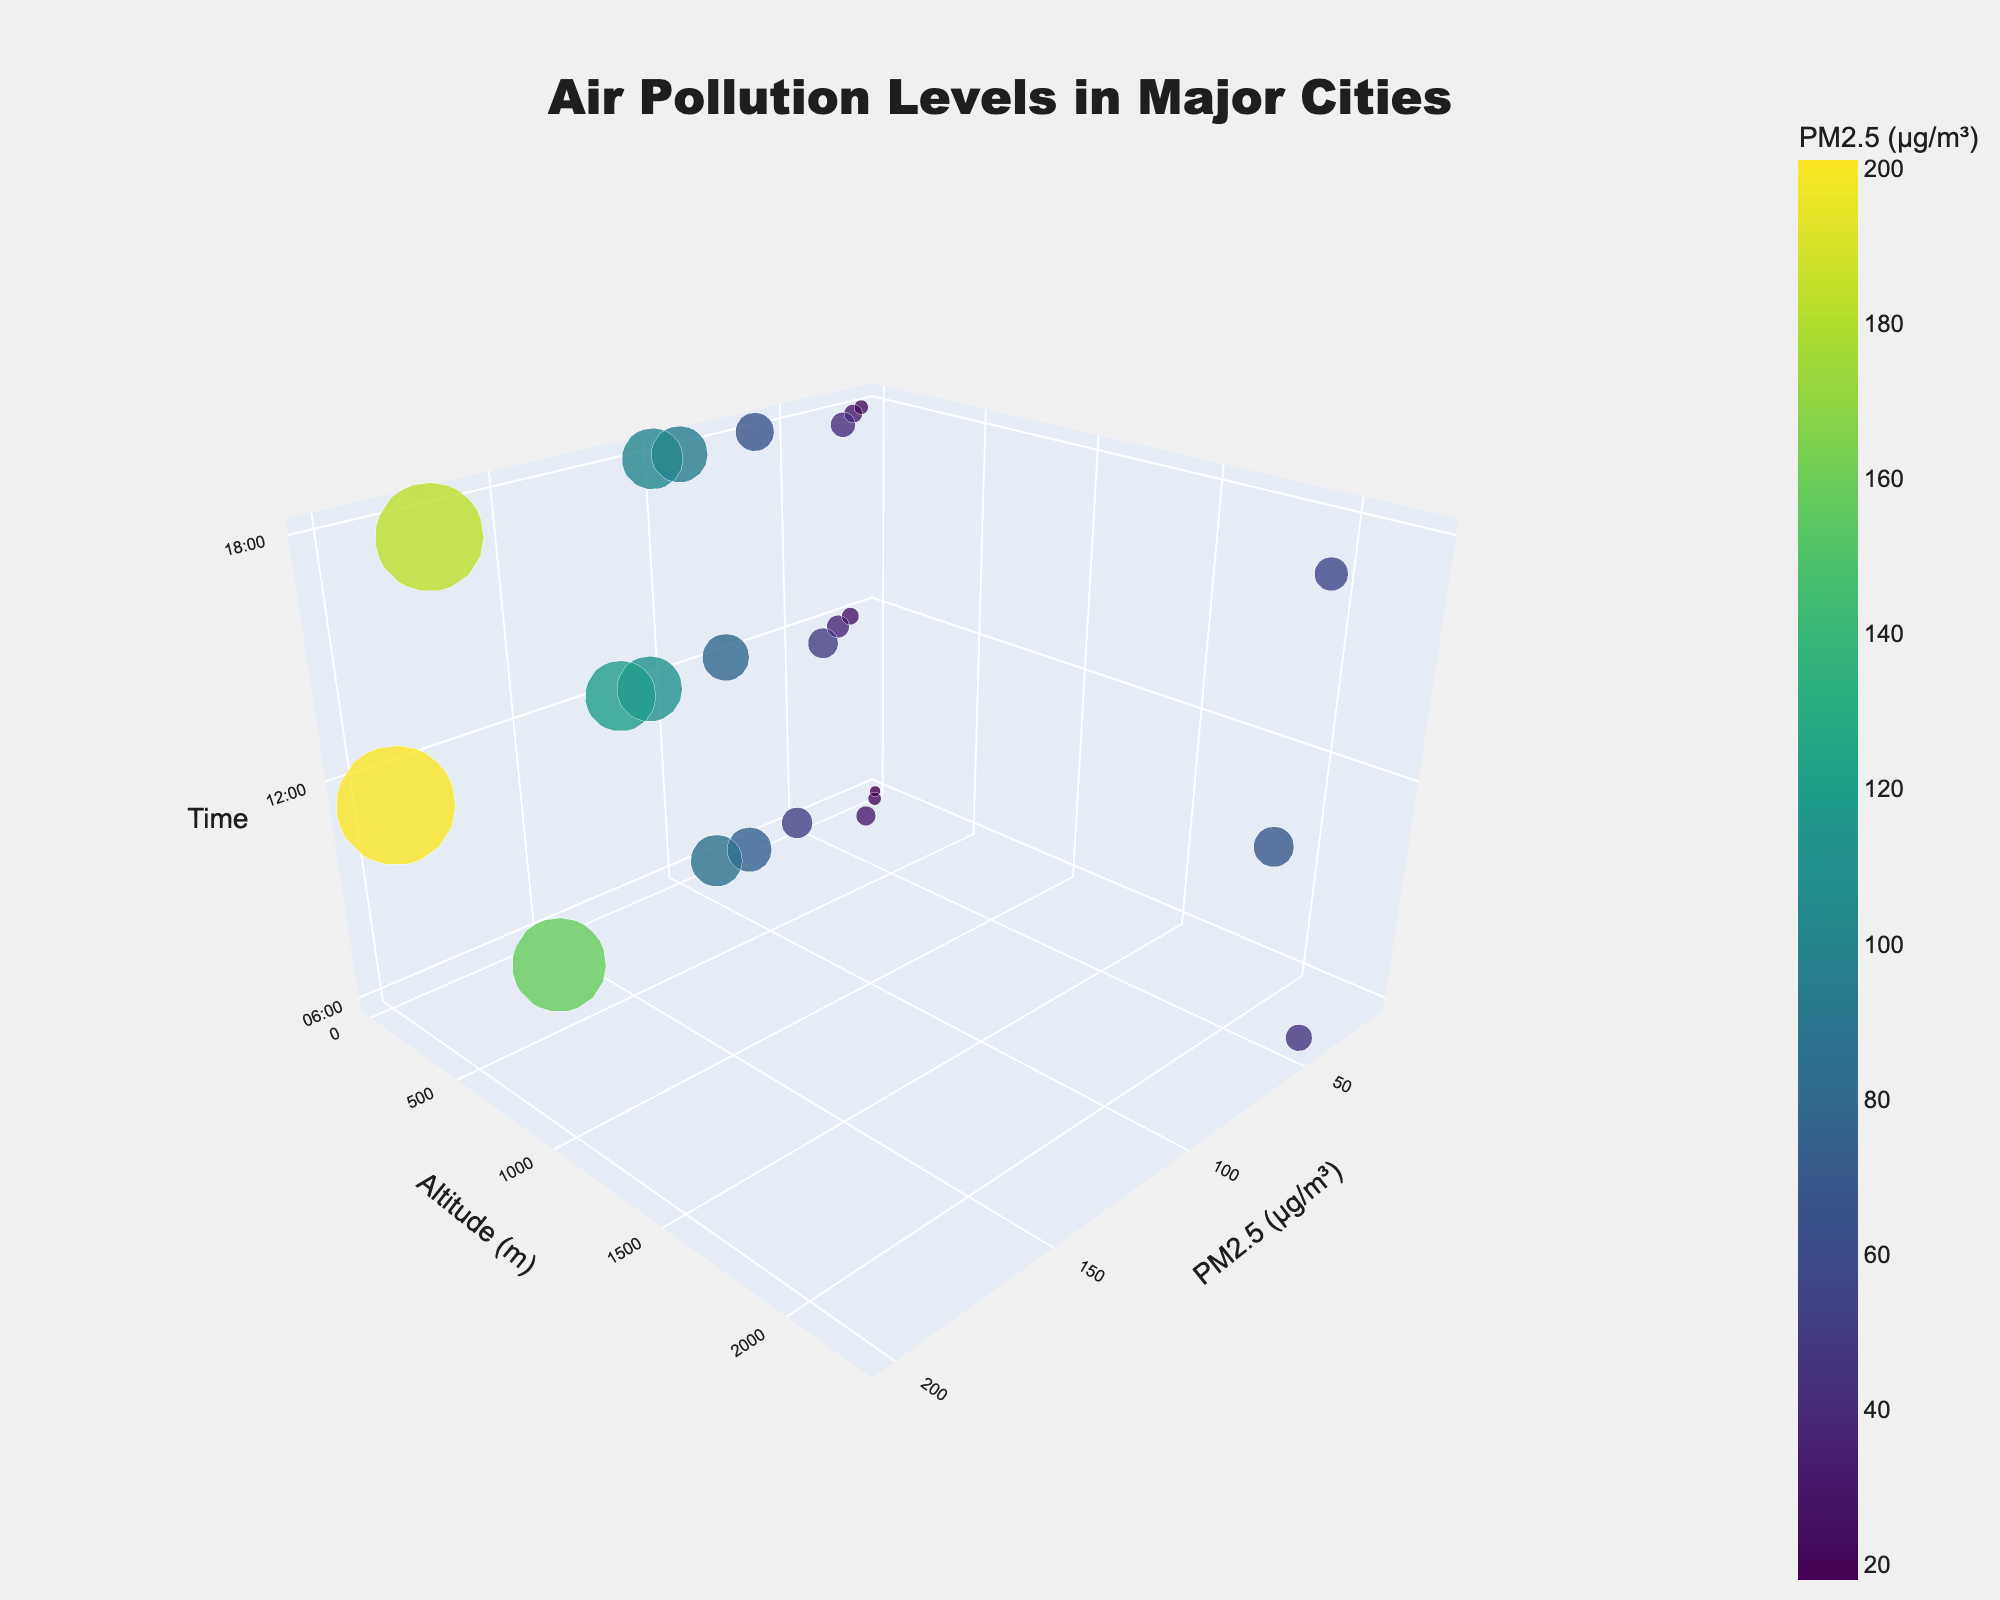What's the title of the figure? The title of the figure is usually written at the top of the chart.
Answer: Air Pollution Levels in Major Cities What are the labels of the axes in the plot? The labels for the axes can be seen alongside each axis. The x-axis is labeled 'PM2.5 (µg/m³)', the y-axis is labeled 'Altitude (m)', and the z-axis is labeled 'Time'.
Answer: PM2.5 (µg/m³), Altitude (m), Time How many cities are represented in the figure? By looking at the different markers and their hover text, we can count the number of unique cities. There are markers for Beijing, Delhi, Los Angeles, Cairo, Mexico City, Jakarta, Moscow, and London.
Answer: 8 Which city has the highest PM2.5 level at any time of the day? By looking at the highest PM2.5 values on the x-axis, we can identify that Delhi has the highest value with PM2.5 at 201 µg/m³ around 12:00.
Answer: Delhi What is the PM2.5 level for Mexico City at 06:00? We need to find the data point with the 'Time' of 06:00 and 'City' as Mexico City and then look at its PM2.5 value which is displayed on the x-axis.
Answer: 45 µg/m³ Among the listed cities, which one has the lowest altitude? By checking the 'Altitude (m)' on the y-axis for all cities, we can observe that Jakarta has the lowest altitude of 8 meters.
Answer: Jakarta Compare the PM2.5 levels in Beijing at 12:00 and Los Angeles at 18:00. Which one is higher? We look at the data points for Beijing at 12:00 and Los Angeles at 18:00 and check their PM2.5 values on the x-axis. Beijing has 110 µg/m³ and Los Angeles has 31 µg/m³.
Answer: Beijing What is the average PM2.5 level in Moscow throughout the day? By checking Moscow's PM2.5 levels at all times (33, 51, and 42 µg/m³), we add these values and divide by 3. The calculation is (33 + 51 + 42) / 3 = 42.
Answer: 42 µg/m³ Which city shows the greatest increase in PM2.5 between 06:00 and 12:00? We compare the increase in PM2.5 levels between 06:00 and 12:00 for all cities. The largest increase is in Delhi from 158 µg/m³ to 201 µg/m³, an increase of 43 µg/m³.
Answer: Delhi 